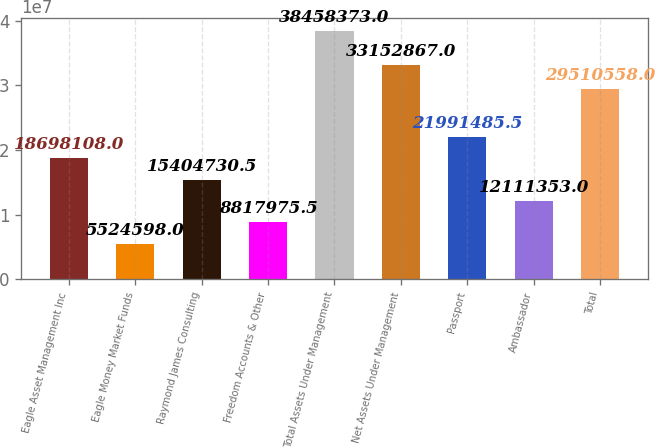Convert chart to OTSL. <chart><loc_0><loc_0><loc_500><loc_500><bar_chart><fcel>Eagle Asset Management Inc<fcel>Eagle Money Market Funds<fcel>Raymond James Consulting<fcel>Freedom Accounts & Other<fcel>Total Assets Under Management<fcel>Net Assets Under Management<fcel>Passport<fcel>Ambassador<fcel>Total<nl><fcel>1.86981e+07<fcel>5.5246e+06<fcel>1.54047e+07<fcel>8.81798e+06<fcel>3.84584e+07<fcel>3.31529e+07<fcel>2.19915e+07<fcel>1.21114e+07<fcel>2.95106e+07<nl></chart> 